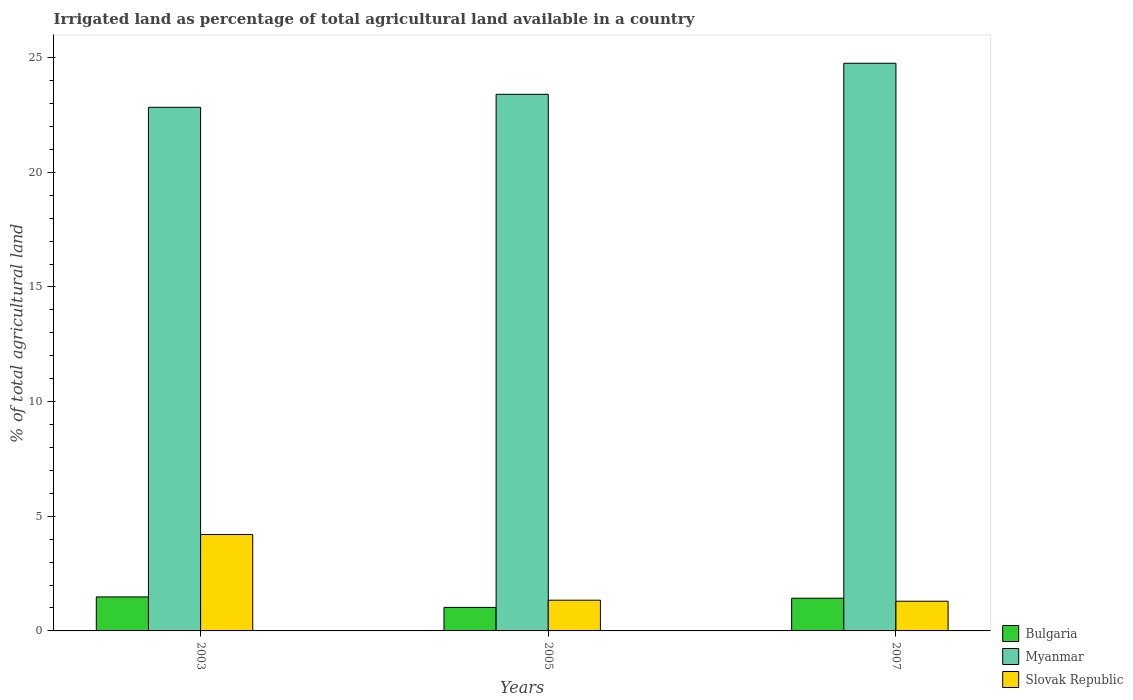Are the number of bars per tick equal to the number of legend labels?
Your answer should be compact. Yes. How many bars are there on the 1st tick from the left?
Ensure brevity in your answer.  3. What is the label of the 2nd group of bars from the left?
Make the answer very short. 2005. What is the percentage of irrigated land in Slovak Republic in 2005?
Offer a terse response. 1.34. Across all years, what is the maximum percentage of irrigated land in Bulgaria?
Ensure brevity in your answer.  1.48. Across all years, what is the minimum percentage of irrigated land in Myanmar?
Your answer should be compact. 22.84. In which year was the percentage of irrigated land in Bulgaria minimum?
Your answer should be compact. 2005. What is the total percentage of irrigated land in Myanmar in the graph?
Give a very brief answer. 71. What is the difference between the percentage of irrigated land in Myanmar in 2003 and that in 2005?
Your answer should be compact. -0.57. What is the difference between the percentage of irrigated land in Myanmar in 2007 and the percentage of irrigated land in Slovak Republic in 2005?
Offer a terse response. 23.42. What is the average percentage of irrigated land in Bulgaria per year?
Offer a very short reply. 1.31. In the year 2007, what is the difference between the percentage of irrigated land in Myanmar and percentage of irrigated land in Bulgaria?
Offer a very short reply. 23.33. What is the ratio of the percentage of irrigated land in Myanmar in 2003 to that in 2005?
Your answer should be very brief. 0.98. What is the difference between the highest and the second highest percentage of irrigated land in Myanmar?
Your answer should be very brief. 1.35. What is the difference between the highest and the lowest percentage of irrigated land in Slovak Republic?
Your answer should be compact. 2.91. In how many years, is the percentage of irrigated land in Slovak Republic greater than the average percentage of irrigated land in Slovak Republic taken over all years?
Offer a terse response. 1. What does the 3rd bar from the left in 2005 represents?
Ensure brevity in your answer.  Slovak Republic. What does the 2nd bar from the right in 2005 represents?
Your answer should be very brief. Myanmar. Is it the case that in every year, the sum of the percentage of irrigated land in Bulgaria and percentage of irrigated land in Slovak Republic is greater than the percentage of irrigated land in Myanmar?
Your answer should be compact. No. Are the values on the major ticks of Y-axis written in scientific E-notation?
Offer a terse response. No. How many legend labels are there?
Offer a very short reply. 3. How are the legend labels stacked?
Give a very brief answer. Vertical. What is the title of the graph?
Provide a short and direct response. Irrigated land as percentage of total agricultural land available in a country. What is the label or title of the X-axis?
Provide a short and direct response. Years. What is the label or title of the Y-axis?
Make the answer very short. % of total agricultural land. What is the % of total agricultural land of Bulgaria in 2003?
Give a very brief answer. 1.48. What is the % of total agricultural land in Myanmar in 2003?
Provide a short and direct response. 22.84. What is the % of total agricultural land of Slovak Republic in 2003?
Ensure brevity in your answer.  4.2. What is the % of total agricultural land of Bulgaria in 2005?
Provide a short and direct response. 1.03. What is the % of total agricultural land of Myanmar in 2005?
Offer a very short reply. 23.4. What is the % of total agricultural land of Slovak Republic in 2005?
Offer a terse response. 1.34. What is the % of total agricultural land of Bulgaria in 2007?
Provide a succinct answer. 1.43. What is the % of total agricultural land of Myanmar in 2007?
Keep it short and to the point. 24.76. What is the % of total agricultural land of Slovak Republic in 2007?
Ensure brevity in your answer.  1.3. Across all years, what is the maximum % of total agricultural land in Bulgaria?
Offer a terse response. 1.48. Across all years, what is the maximum % of total agricultural land of Myanmar?
Provide a succinct answer. 24.76. Across all years, what is the maximum % of total agricultural land of Slovak Republic?
Your answer should be compact. 4.2. Across all years, what is the minimum % of total agricultural land of Bulgaria?
Offer a terse response. 1.03. Across all years, what is the minimum % of total agricultural land in Myanmar?
Your response must be concise. 22.84. Across all years, what is the minimum % of total agricultural land of Slovak Republic?
Offer a very short reply. 1.3. What is the total % of total agricultural land of Bulgaria in the graph?
Provide a succinct answer. 3.94. What is the total % of total agricultural land in Myanmar in the graph?
Provide a succinct answer. 71. What is the total % of total agricultural land of Slovak Republic in the graph?
Ensure brevity in your answer.  6.84. What is the difference between the % of total agricultural land in Bulgaria in 2003 and that in 2005?
Ensure brevity in your answer.  0.46. What is the difference between the % of total agricultural land in Myanmar in 2003 and that in 2005?
Ensure brevity in your answer.  -0.57. What is the difference between the % of total agricultural land of Slovak Republic in 2003 and that in 2005?
Provide a short and direct response. 2.86. What is the difference between the % of total agricultural land in Bulgaria in 2003 and that in 2007?
Provide a short and direct response. 0.06. What is the difference between the % of total agricultural land of Myanmar in 2003 and that in 2007?
Ensure brevity in your answer.  -1.92. What is the difference between the % of total agricultural land of Slovak Republic in 2003 and that in 2007?
Offer a terse response. 2.91. What is the difference between the % of total agricultural land in Bulgaria in 2005 and that in 2007?
Offer a very short reply. -0.4. What is the difference between the % of total agricultural land of Myanmar in 2005 and that in 2007?
Keep it short and to the point. -1.35. What is the difference between the % of total agricultural land of Slovak Republic in 2005 and that in 2007?
Your answer should be very brief. 0.04. What is the difference between the % of total agricultural land in Bulgaria in 2003 and the % of total agricultural land in Myanmar in 2005?
Offer a terse response. -21.92. What is the difference between the % of total agricultural land in Bulgaria in 2003 and the % of total agricultural land in Slovak Republic in 2005?
Ensure brevity in your answer.  0.14. What is the difference between the % of total agricultural land of Myanmar in 2003 and the % of total agricultural land of Slovak Republic in 2005?
Offer a terse response. 21.5. What is the difference between the % of total agricultural land of Bulgaria in 2003 and the % of total agricultural land of Myanmar in 2007?
Keep it short and to the point. -23.27. What is the difference between the % of total agricultural land of Bulgaria in 2003 and the % of total agricultural land of Slovak Republic in 2007?
Provide a succinct answer. 0.19. What is the difference between the % of total agricultural land of Myanmar in 2003 and the % of total agricultural land of Slovak Republic in 2007?
Your response must be concise. 21.54. What is the difference between the % of total agricultural land in Bulgaria in 2005 and the % of total agricultural land in Myanmar in 2007?
Your response must be concise. -23.73. What is the difference between the % of total agricultural land of Bulgaria in 2005 and the % of total agricultural land of Slovak Republic in 2007?
Give a very brief answer. -0.27. What is the difference between the % of total agricultural land of Myanmar in 2005 and the % of total agricultural land of Slovak Republic in 2007?
Offer a very short reply. 22.11. What is the average % of total agricultural land of Bulgaria per year?
Offer a very short reply. 1.31. What is the average % of total agricultural land in Myanmar per year?
Provide a short and direct response. 23.67. What is the average % of total agricultural land in Slovak Republic per year?
Your response must be concise. 2.28. In the year 2003, what is the difference between the % of total agricultural land of Bulgaria and % of total agricultural land of Myanmar?
Provide a succinct answer. -21.35. In the year 2003, what is the difference between the % of total agricultural land in Bulgaria and % of total agricultural land in Slovak Republic?
Your answer should be compact. -2.72. In the year 2003, what is the difference between the % of total agricultural land of Myanmar and % of total agricultural land of Slovak Republic?
Provide a succinct answer. 18.63. In the year 2005, what is the difference between the % of total agricultural land in Bulgaria and % of total agricultural land in Myanmar?
Your answer should be very brief. -22.38. In the year 2005, what is the difference between the % of total agricultural land in Bulgaria and % of total agricultural land in Slovak Republic?
Make the answer very short. -0.31. In the year 2005, what is the difference between the % of total agricultural land of Myanmar and % of total agricultural land of Slovak Republic?
Your answer should be compact. 22.06. In the year 2007, what is the difference between the % of total agricultural land of Bulgaria and % of total agricultural land of Myanmar?
Ensure brevity in your answer.  -23.33. In the year 2007, what is the difference between the % of total agricultural land in Bulgaria and % of total agricultural land in Slovak Republic?
Provide a succinct answer. 0.13. In the year 2007, what is the difference between the % of total agricultural land in Myanmar and % of total agricultural land in Slovak Republic?
Provide a short and direct response. 23.46. What is the ratio of the % of total agricultural land in Bulgaria in 2003 to that in 2005?
Your answer should be compact. 1.45. What is the ratio of the % of total agricultural land in Myanmar in 2003 to that in 2005?
Keep it short and to the point. 0.98. What is the ratio of the % of total agricultural land in Slovak Republic in 2003 to that in 2005?
Your answer should be very brief. 3.14. What is the ratio of the % of total agricultural land of Bulgaria in 2003 to that in 2007?
Provide a short and direct response. 1.04. What is the ratio of the % of total agricultural land in Myanmar in 2003 to that in 2007?
Your response must be concise. 0.92. What is the ratio of the % of total agricultural land of Slovak Republic in 2003 to that in 2007?
Offer a very short reply. 3.25. What is the ratio of the % of total agricultural land in Bulgaria in 2005 to that in 2007?
Keep it short and to the point. 0.72. What is the ratio of the % of total agricultural land of Myanmar in 2005 to that in 2007?
Ensure brevity in your answer.  0.95. What is the ratio of the % of total agricultural land in Slovak Republic in 2005 to that in 2007?
Keep it short and to the point. 1.03. What is the difference between the highest and the second highest % of total agricultural land of Bulgaria?
Your answer should be compact. 0.06. What is the difference between the highest and the second highest % of total agricultural land of Myanmar?
Ensure brevity in your answer.  1.35. What is the difference between the highest and the second highest % of total agricultural land of Slovak Republic?
Your answer should be compact. 2.86. What is the difference between the highest and the lowest % of total agricultural land of Bulgaria?
Your response must be concise. 0.46. What is the difference between the highest and the lowest % of total agricultural land in Myanmar?
Offer a very short reply. 1.92. What is the difference between the highest and the lowest % of total agricultural land of Slovak Republic?
Make the answer very short. 2.91. 